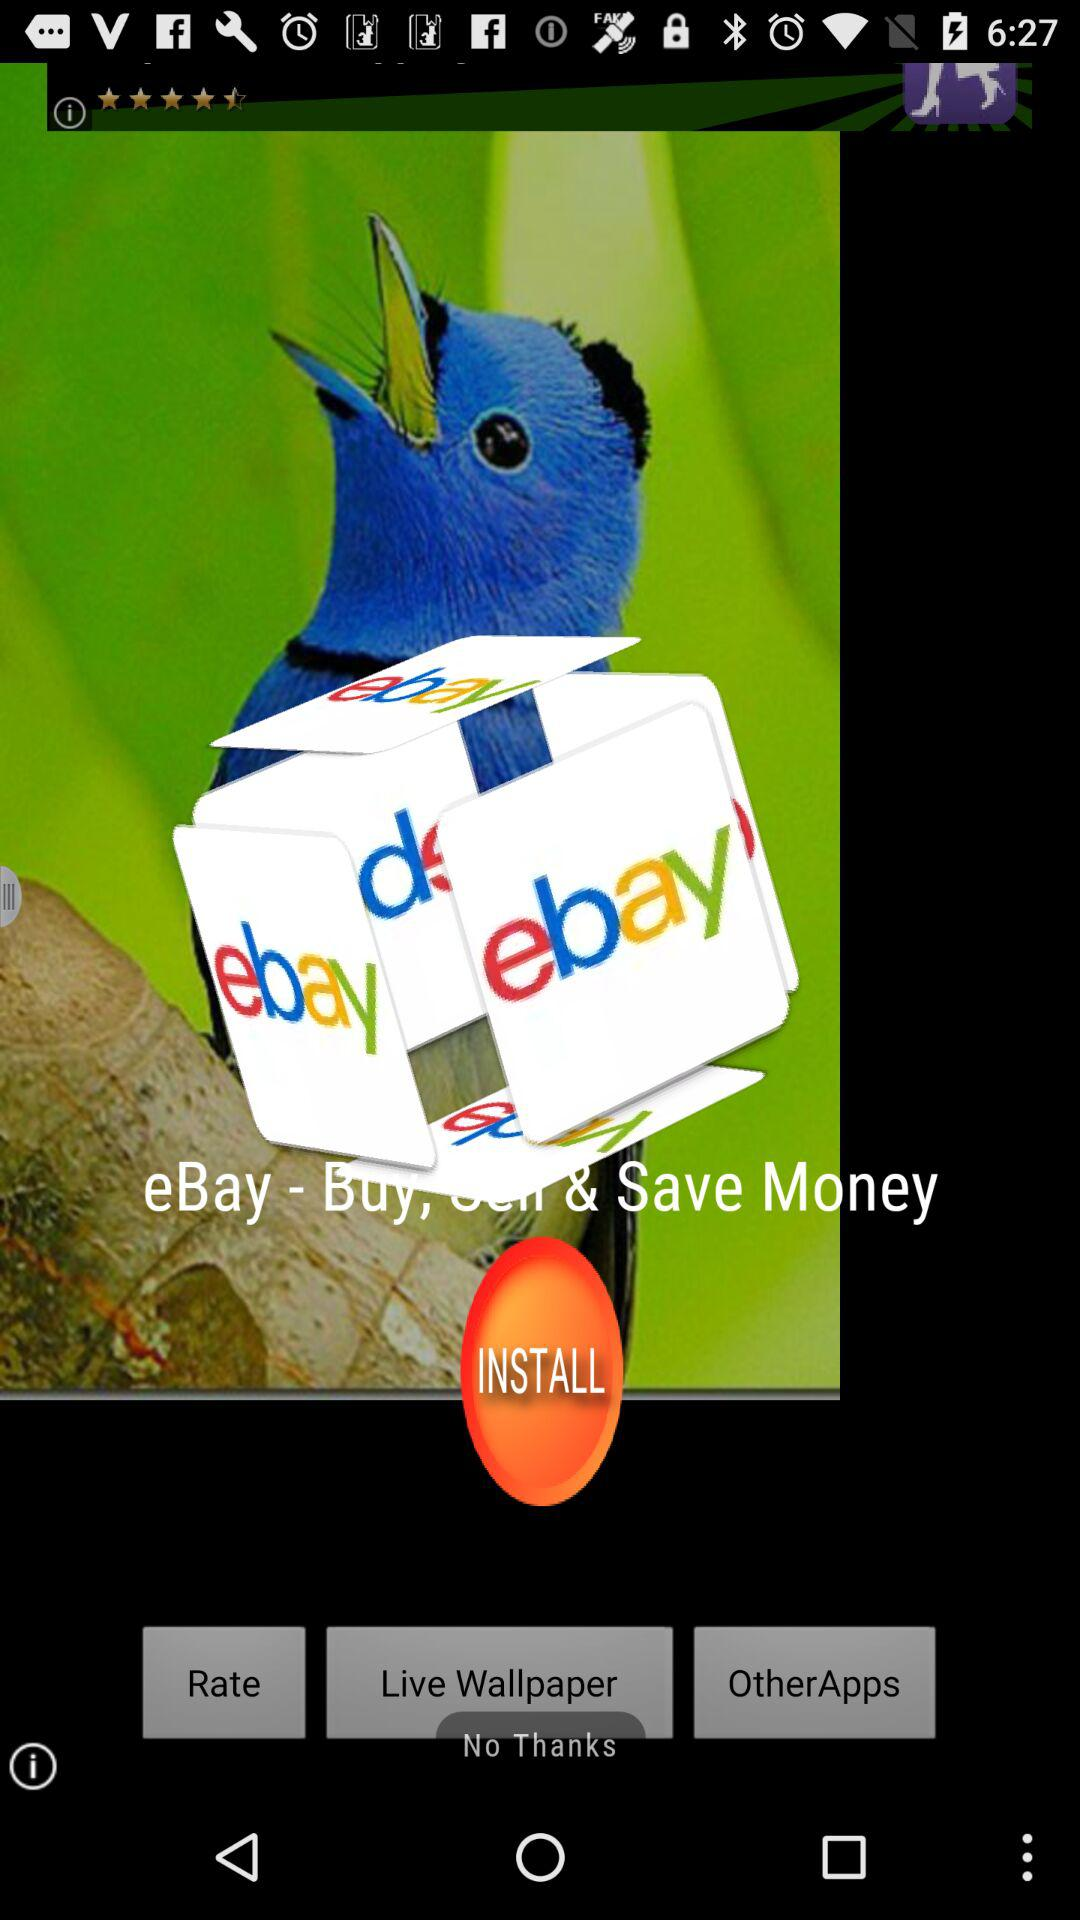What can we do with eBay? We can "Buy, Sell & Save Money" with eBay. 